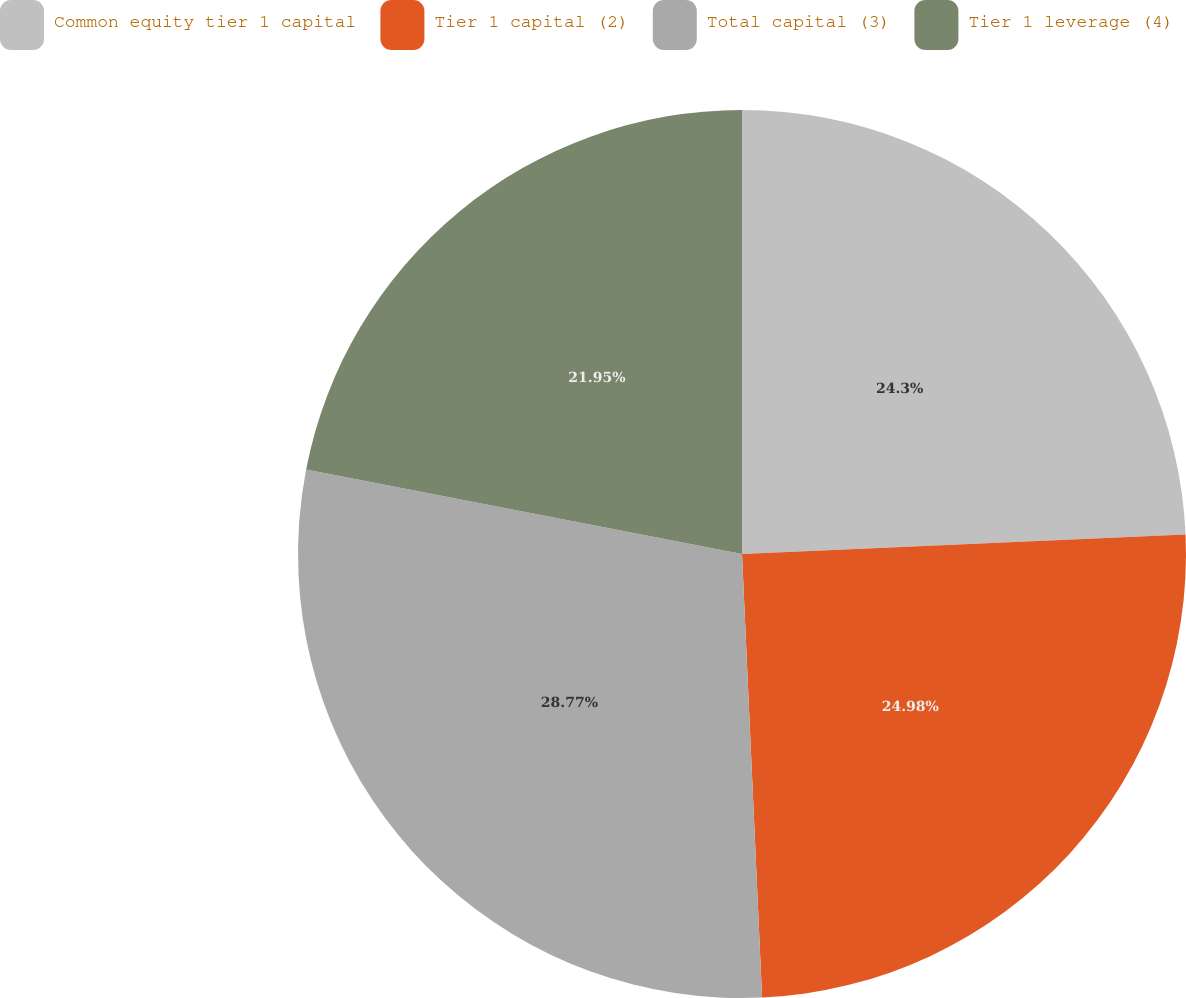Convert chart. <chart><loc_0><loc_0><loc_500><loc_500><pie_chart><fcel>Common equity tier 1 capital<fcel>Tier 1 capital (2)<fcel>Total capital (3)<fcel>Tier 1 leverage (4)<nl><fcel>24.3%<fcel>24.98%<fcel>28.77%<fcel>21.95%<nl></chart> 